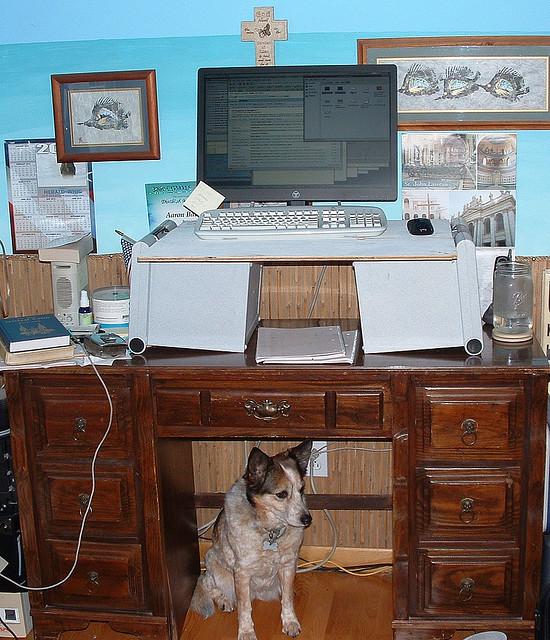Could this desk contraption fit on a modified wheelchair?
Answer briefly. No. Does the owner of this computer work standing up?
Be succinct. Yes. What animal is this?
Quick response, please. Dog. Is the dog a puppy?
Be succinct. No. 